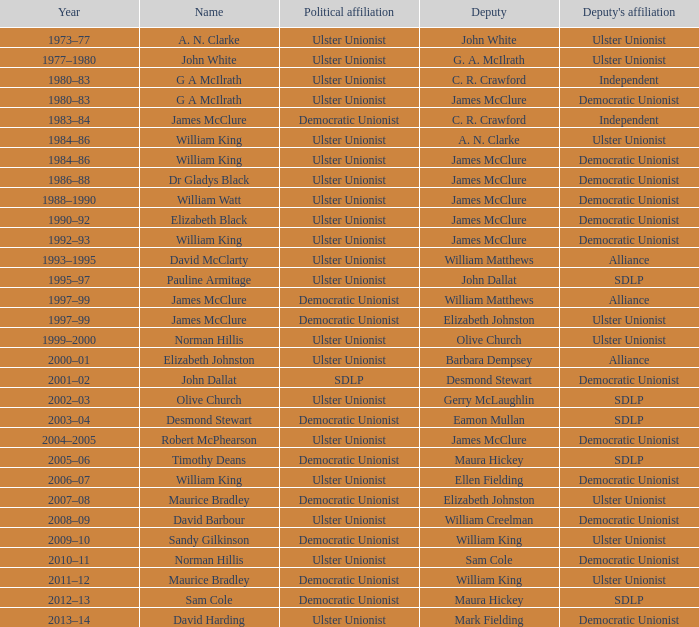What is the name of the deputy in 1992–93? James McClure. 